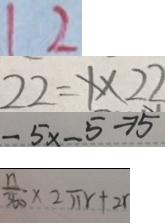Convert formula to latex. <formula><loc_0><loc_0><loc_500><loc_500>1 2 
 2 2 = 1 \times 2 2 
 - 5 x - 5 \rightarrow 5 
 \frac { n } { 3 6 0 } \times 2 \pi r + 2 r</formula> 